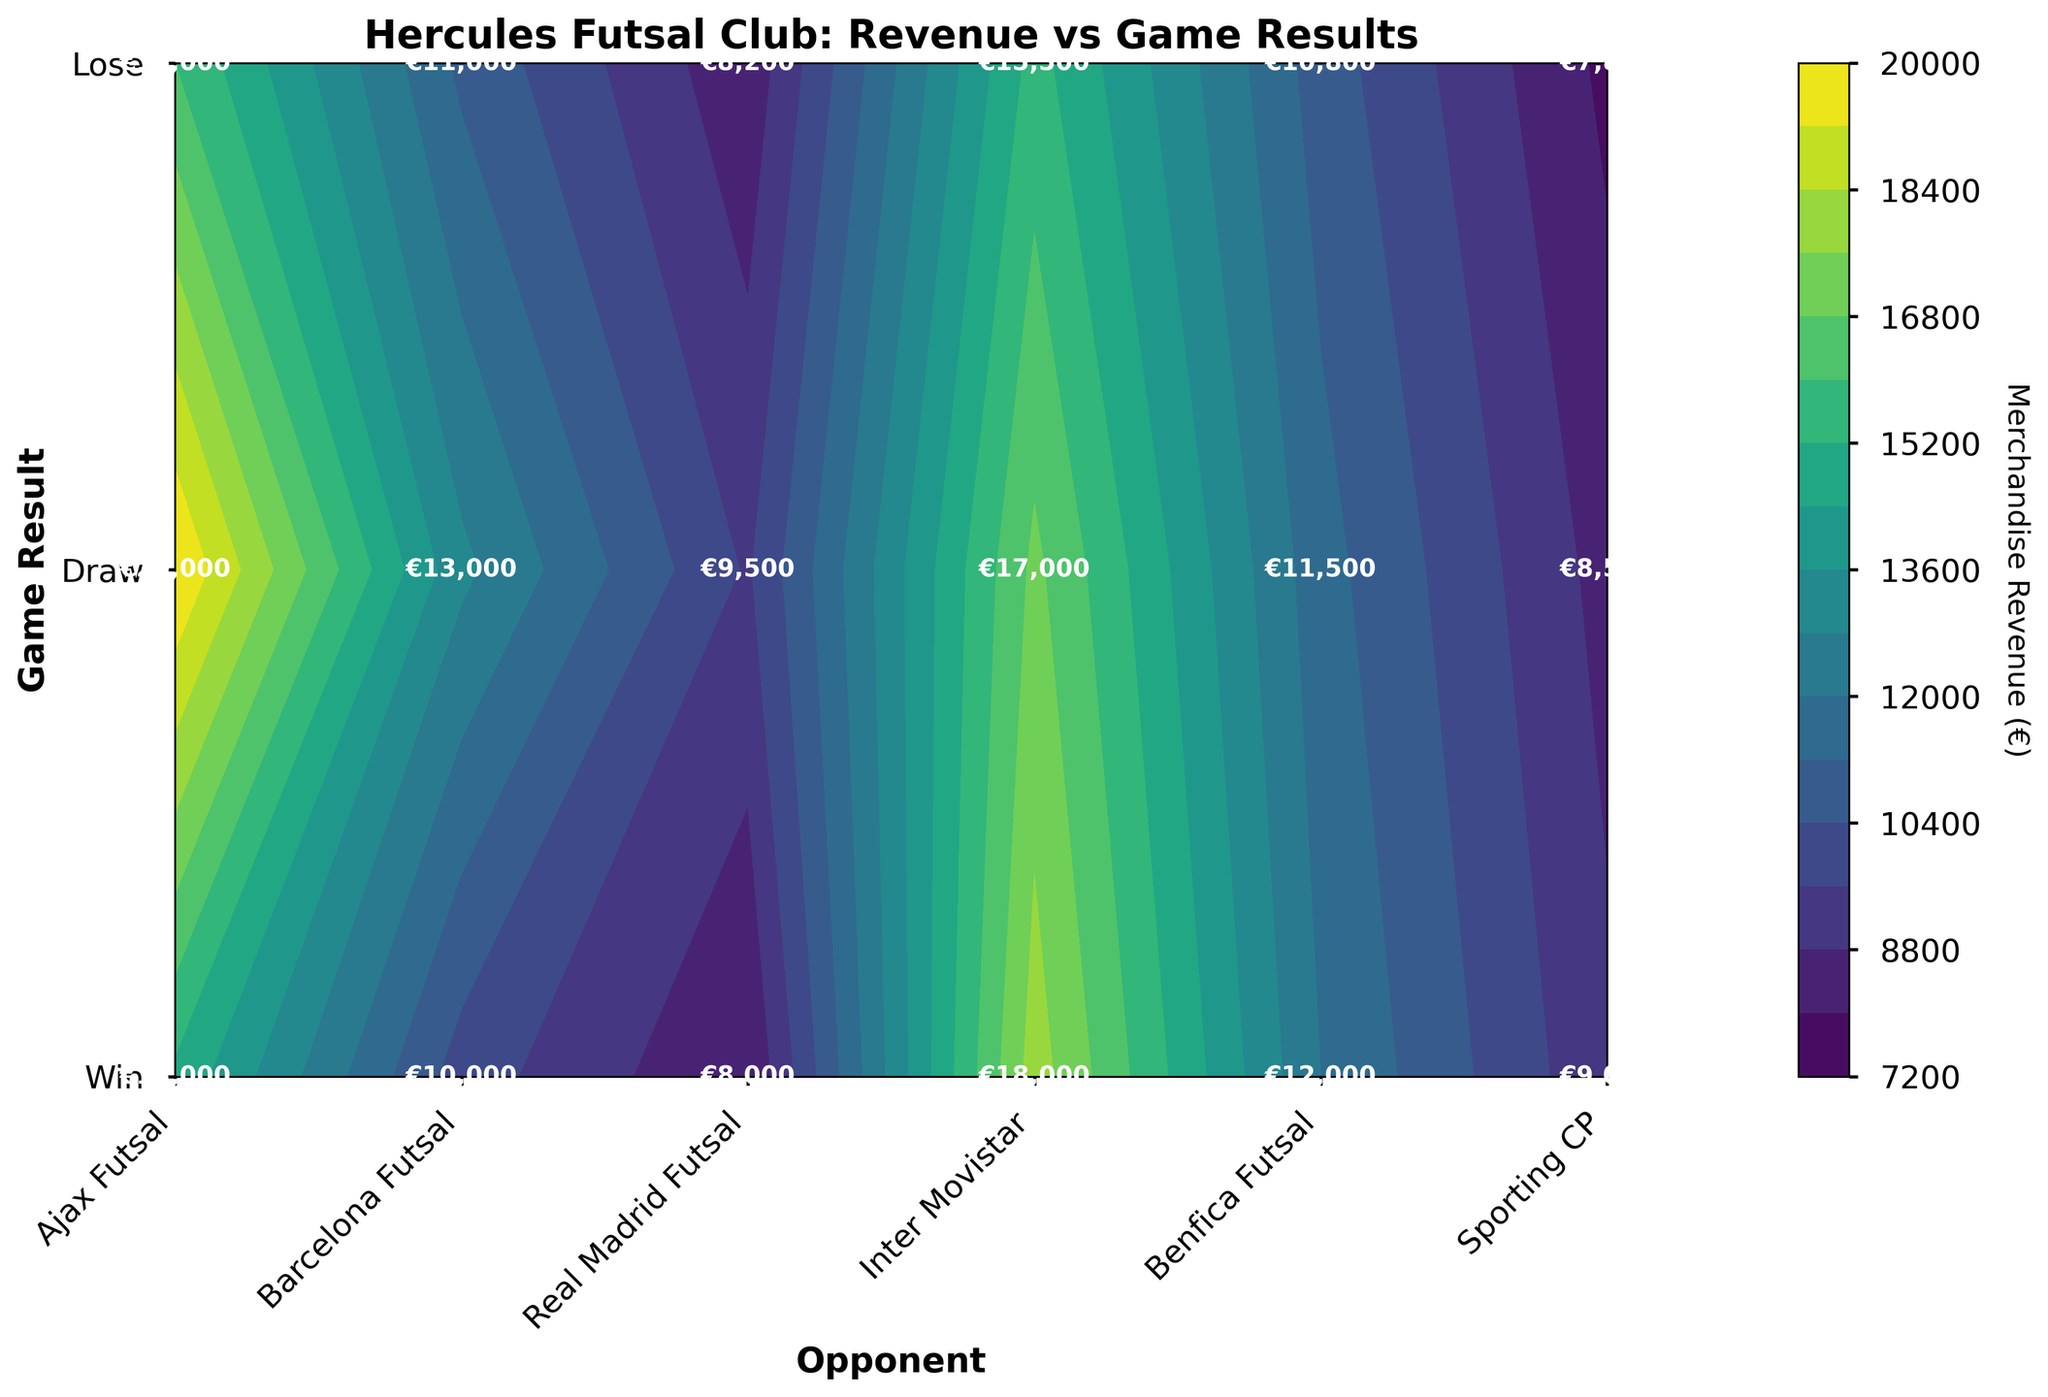What is the highest merchandise revenue generated for a win? Look at the highest value in the contour plot under the "Win" row. Based on the data values annotated in the plot, find the maximum value.
Answer: €20,000 Which opponent generated the least revenue when the game resulted in a draw? Examine the "Draw" row and compare the values for each opponent. The lowest value corresponds to the opponent.
Answer: Sporting CP Is there a significant difference in revenue between a win and a loss against Barcelona Futsal? Check the values for wins and losses against Barcelona Futsal. We see €18,000 for a win and €9,000 for a loss. The difference is €18,000 - €9,000 = €9,000, illustrating a significant difference.
Answer: €9,000 What is the average revenue generated for games that resulted in a draw? Sum all the merchandise revenue values in the "Draw" row and divide by the number of opponents. Calculation: (€10,000 + €12,000 + €13,000 + €11,500 + €11,000 + €10,800) / 6 = €11,550.
Answer: €11,550 Which game result yielded the highest merchandise revenue for Ajax Futsal? Examine the values under the Ajax Futsal column and identify the highest value. The row with the highest value gives the game result.
Answer: Win How does the merchandise revenue compare for a win against Real Madrid Futsal versus a win against Inter Movistar? Compare the "Win" values for Real Madrid Futsal (€20,000) and Inter Movistar (€17,000). Real Madrid generates €3,000 more revenue.
Answer: Real Madrid by €3,000 Which game result consistently brings in the highest revenue across all opponents? Look across all rows and find the overall highest values. The highest values consistently appear in the "Win" row.
Answer: Win What is the total merchandise revenue for all games against Benfica Futsal? Add all revenues associated with Benfica Futsal: (€16,000 + €11,000 + €8,200). Total = €35,200.
Answer: €35,200 How does the revenue from Inter Movistar draws compare to draws against Barcelona Futsal? Compare the "Draw" values for Inter Movistar (€11,500) and Barcelona Futsal (€12,000). Barcelona Futsal has a slightly higher revenue by €500.
Answer: Barcelona Futsal by €500 